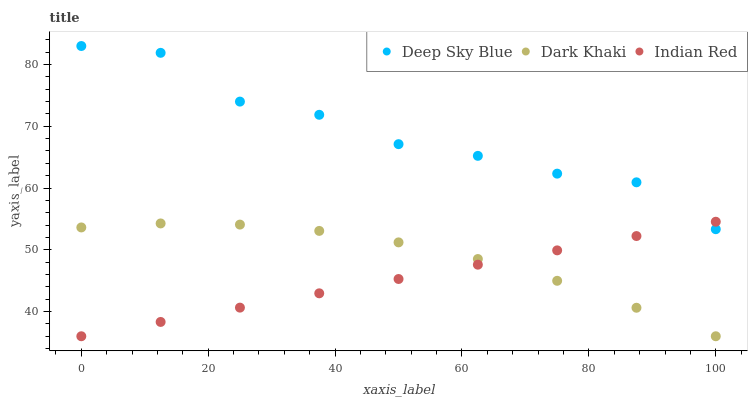Does Indian Red have the minimum area under the curve?
Answer yes or no. Yes. Does Deep Sky Blue have the maximum area under the curve?
Answer yes or no. Yes. Does Deep Sky Blue have the minimum area under the curve?
Answer yes or no. No. Does Indian Red have the maximum area under the curve?
Answer yes or no. No. Is Indian Red the smoothest?
Answer yes or no. Yes. Is Deep Sky Blue the roughest?
Answer yes or no. Yes. Is Deep Sky Blue the smoothest?
Answer yes or no. No. Is Indian Red the roughest?
Answer yes or no. No. Does Dark Khaki have the lowest value?
Answer yes or no. Yes. Does Deep Sky Blue have the lowest value?
Answer yes or no. No. Does Deep Sky Blue have the highest value?
Answer yes or no. Yes. Does Indian Red have the highest value?
Answer yes or no. No. Is Dark Khaki less than Deep Sky Blue?
Answer yes or no. Yes. Is Deep Sky Blue greater than Dark Khaki?
Answer yes or no. Yes. Does Dark Khaki intersect Indian Red?
Answer yes or no. Yes. Is Dark Khaki less than Indian Red?
Answer yes or no. No. Is Dark Khaki greater than Indian Red?
Answer yes or no. No. Does Dark Khaki intersect Deep Sky Blue?
Answer yes or no. No. 